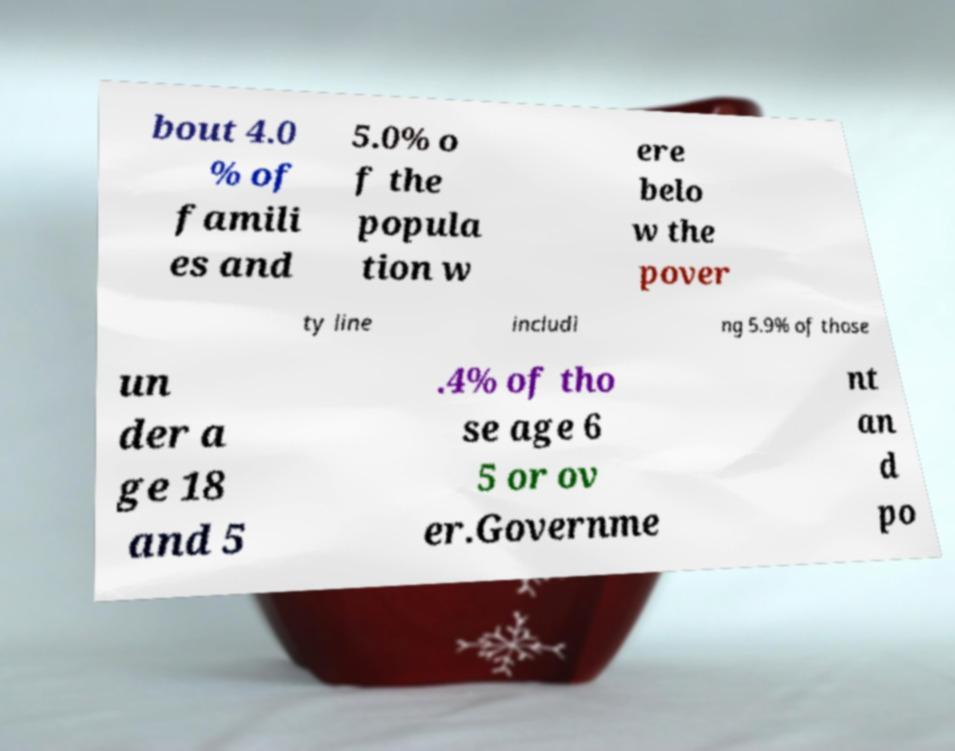There's text embedded in this image that I need extracted. Can you transcribe it verbatim? bout 4.0 % of famili es and 5.0% o f the popula tion w ere belo w the pover ty line includi ng 5.9% of those un der a ge 18 and 5 .4% of tho se age 6 5 or ov er.Governme nt an d po 